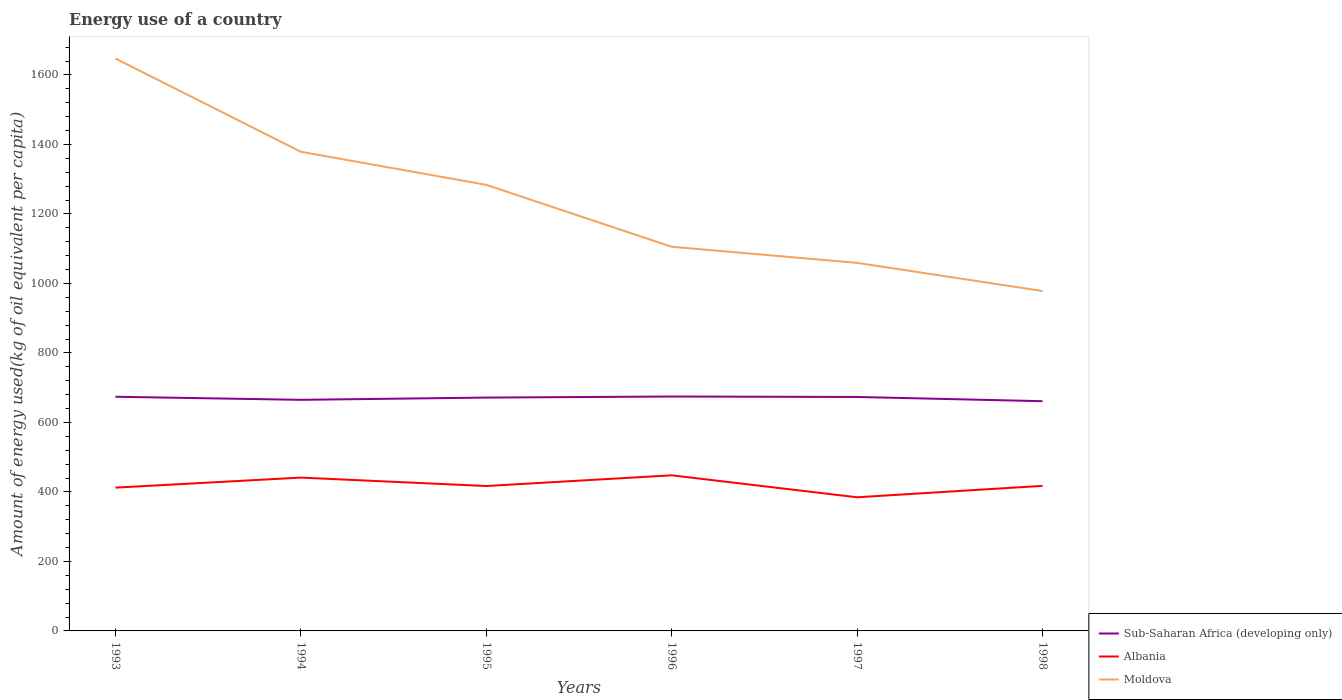Does the line corresponding to Albania intersect with the line corresponding to Moldova?
Provide a succinct answer. No. Is the number of lines equal to the number of legend labels?
Offer a terse response. Yes. Across all years, what is the maximum amount of energy used in in Moldova?
Provide a succinct answer. 978.23. In which year was the amount of energy used in in Sub-Saharan Africa (developing only) maximum?
Make the answer very short. 1998. What is the total amount of energy used in in Sub-Saharan Africa (developing only) in the graph?
Keep it short and to the point. -9.53. What is the difference between the highest and the second highest amount of energy used in in Albania?
Give a very brief answer. 63.25. Is the amount of energy used in in Moldova strictly greater than the amount of energy used in in Albania over the years?
Provide a succinct answer. No. How many lines are there?
Provide a short and direct response. 3. How many years are there in the graph?
Give a very brief answer. 6. What is the difference between two consecutive major ticks on the Y-axis?
Your answer should be very brief. 200. Are the values on the major ticks of Y-axis written in scientific E-notation?
Make the answer very short. No. Does the graph contain any zero values?
Give a very brief answer. No. Does the graph contain grids?
Ensure brevity in your answer.  No. Where does the legend appear in the graph?
Offer a very short reply. Bottom right. How are the legend labels stacked?
Make the answer very short. Vertical. What is the title of the graph?
Make the answer very short. Energy use of a country. What is the label or title of the X-axis?
Your answer should be very brief. Years. What is the label or title of the Y-axis?
Keep it short and to the point. Amount of energy used(kg of oil equivalent per capita). What is the Amount of energy used(kg of oil equivalent per capita) of Sub-Saharan Africa (developing only) in 1993?
Provide a succinct answer. 673.9. What is the Amount of energy used(kg of oil equivalent per capita) in Albania in 1993?
Provide a succinct answer. 412.38. What is the Amount of energy used(kg of oil equivalent per capita) in Moldova in 1993?
Provide a succinct answer. 1647.32. What is the Amount of energy used(kg of oil equivalent per capita) in Sub-Saharan Africa (developing only) in 1994?
Offer a very short reply. 665.05. What is the Amount of energy used(kg of oil equivalent per capita) in Albania in 1994?
Give a very brief answer. 441.25. What is the Amount of energy used(kg of oil equivalent per capita) of Moldova in 1994?
Ensure brevity in your answer.  1378.97. What is the Amount of energy used(kg of oil equivalent per capita) of Sub-Saharan Africa (developing only) in 1995?
Provide a short and direct response. 671.53. What is the Amount of energy used(kg of oil equivalent per capita) of Albania in 1995?
Ensure brevity in your answer.  417.03. What is the Amount of energy used(kg of oil equivalent per capita) of Moldova in 1995?
Make the answer very short. 1283.8. What is the Amount of energy used(kg of oil equivalent per capita) of Sub-Saharan Africa (developing only) in 1996?
Give a very brief answer. 674.58. What is the Amount of energy used(kg of oil equivalent per capita) in Albania in 1996?
Your answer should be compact. 447.85. What is the Amount of energy used(kg of oil equivalent per capita) of Moldova in 1996?
Your response must be concise. 1105.57. What is the Amount of energy used(kg of oil equivalent per capita) of Sub-Saharan Africa (developing only) in 1997?
Provide a succinct answer. 673.28. What is the Amount of energy used(kg of oil equivalent per capita) in Albania in 1997?
Provide a short and direct response. 384.59. What is the Amount of energy used(kg of oil equivalent per capita) of Moldova in 1997?
Give a very brief answer. 1059.24. What is the Amount of energy used(kg of oil equivalent per capita) of Sub-Saharan Africa (developing only) in 1998?
Offer a very short reply. 661.13. What is the Amount of energy used(kg of oil equivalent per capita) of Albania in 1998?
Provide a short and direct response. 417.52. What is the Amount of energy used(kg of oil equivalent per capita) in Moldova in 1998?
Give a very brief answer. 978.23. Across all years, what is the maximum Amount of energy used(kg of oil equivalent per capita) of Sub-Saharan Africa (developing only)?
Your answer should be compact. 674.58. Across all years, what is the maximum Amount of energy used(kg of oil equivalent per capita) of Albania?
Keep it short and to the point. 447.85. Across all years, what is the maximum Amount of energy used(kg of oil equivalent per capita) in Moldova?
Offer a terse response. 1647.32. Across all years, what is the minimum Amount of energy used(kg of oil equivalent per capita) in Sub-Saharan Africa (developing only)?
Offer a very short reply. 661.13. Across all years, what is the minimum Amount of energy used(kg of oil equivalent per capita) in Albania?
Your answer should be compact. 384.59. Across all years, what is the minimum Amount of energy used(kg of oil equivalent per capita) of Moldova?
Your response must be concise. 978.23. What is the total Amount of energy used(kg of oil equivalent per capita) of Sub-Saharan Africa (developing only) in the graph?
Your response must be concise. 4019.47. What is the total Amount of energy used(kg of oil equivalent per capita) in Albania in the graph?
Provide a short and direct response. 2520.63. What is the total Amount of energy used(kg of oil equivalent per capita) of Moldova in the graph?
Your answer should be very brief. 7453.13. What is the difference between the Amount of energy used(kg of oil equivalent per capita) of Sub-Saharan Africa (developing only) in 1993 and that in 1994?
Give a very brief answer. 8.85. What is the difference between the Amount of energy used(kg of oil equivalent per capita) in Albania in 1993 and that in 1994?
Your response must be concise. -28.87. What is the difference between the Amount of energy used(kg of oil equivalent per capita) of Moldova in 1993 and that in 1994?
Your response must be concise. 268.35. What is the difference between the Amount of energy used(kg of oil equivalent per capita) of Sub-Saharan Africa (developing only) in 1993 and that in 1995?
Keep it short and to the point. 2.37. What is the difference between the Amount of energy used(kg of oil equivalent per capita) in Albania in 1993 and that in 1995?
Provide a short and direct response. -4.66. What is the difference between the Amount of energy used(kg of oil equivalent per capita) in Moldova in 1993 and that in 1995?
Provide a short and direct response. 363.52. What is the difference between the Amount of energy used(kg of oil equivalent per capita) of Sub-Saharan Africa (developing only) in 1993 and that in 1996?
Your answer should be very brief. -0.68. What is the difference between the Amount of energy used(kg of oil equivalent per capita) of Albania in 1993 and that in 1996?
Your answer should be very brief. -35.47. What is the difference between the Amount of energy used(kg of oil equivalent per capita) of Moldova in 1993 and that in 1996?
Provide a succinct answer. 541.75. What is the difference between the Amount of energy used(kg of oil equivalent per capita) of Sub-Saharan Africa (developing only) in 1993 and that in 1997?
Provide a succinct answer. 0.62. What is the difference between the Amount of energy used(kg of oil equivalent per capita) of Albania in 1993 and that in 1997?
Offer a terse response. 27.78. What is the difference between the Amount of energy used(kg of oil equivalent per capita) of Moldova in 1993 and that in 1997?
Offer a terse response. 588.08. What is the difference between the Amount of energy used(kg of oil equivalent per capita) in Sub-Saharan Africa (developing only) in 1993 and that in 1998?
Keep it short and to the point. 12.77. What is the difference between the Amount of energy used(kg of oil equivalent per capita) of Albania in 1993 and that in 1998?
Give a very brief answer. -5.14. What is the difference between the Amount of energy used(kg of oil equivalent per capita) in Moldova in 1993 and that in 1998?
Offer a very short reply. 669.09. What is the difference between the Amount of energy used(kg of oil equivalent per capita) of Sub-Saharan Africa (developing only) in 1994 and that in 1995?
Your answer should be very brief. -6.49. What is the difference between the Amount of energy used(kg of oil equivalent per capita) in Albania in 1994 and that in 1995?
Provide a succinct answer. 24.21. What is the difference between the Amount of energy used(kg of oil equivalent per capita) in Moldova in 1994 and that in 1995?
Give a very brief answer. 95.17. What is the difference between the Amount of energy used(kg of oil equivalent per capita) of Sub-Saharan Africa (developing only) in 1994 and that in 1996?
Provide a succinct answer. -9.53. What is the difference between the Amount of energy used(kg of oil equivalent per capita) in Albania in 1994 and that in 1996?
Provide a succinct answer. -6.6. What is the difference between the Amount of energy used(kg of oil equivalent per capita) of Moldova in 1994 and that in 1996?
Provide a succinct answer. 273.4. What is the difference between the Amount of energy used(kg of oil equivalent per capita) of Sub-Saharan Africa (developing only) in 1994 and that in 1997?
Provide a short and direct response. -8.23. What is the difference between the Amount of energy used(kg of oil equivalent per capita) of Albania in 1994 and that in 1997?
Keep it short and to the point. 56.65. What is the difference between the Amount of energy used(kg of oil equivalent per capita) of Moldova in 1994 and that in 1997?
Your answer should be compact. 319.73. What is the difference between the Amount of energy used(kg of oil equivalent per capita) in Sub-Saharan Africa (developing only) in 1994 and that in 1998?
Your response must be concise. 3.91. What is the difference between the Amount of energy used(kg of oil equivalent per capita) of Albania in 1994 and that in 1998?
Ensure brevity in your answer.  23.73. What is the difference between the Amount of energy used(kg of oil equivalent per capita) of Moldova in 1994 and that in 1998?
Provide a succinct answer. 400.74. What is the difference between the Amount of energy used(kg of oil equivalent per capita) of Sub-Saharan Africa (developing only) in 1995 and that in 1996?
Offer a terse response. -3.04. What is the difference between the Amount of energy used(kg of oil equivalent per capita) of Albania in 1995 and that in 1996?
Your response must be concise. -30.81. What is the difference between the Amount of energy used(kg of oil equivalent per capita) in Moldova in 1995 and that in 1996?
Provide a succinct answer. 178.23. What is the difference between the Amount of energy used(kg of oil equivalent per capita) in Sub-Saharan Africa (developing only) in 1995 and that in 1997?
Provide a short and direct response. -1.75. What is the difference between the Amount of energy used(kg of oil equivalent per capita) in Albania in 1995 and that in 1997?
Your answer should be very brief. 32.44. What is the difference between the Amount of energy used(kg of oil equivalent per capita) in Moldova in 1995 and that in 1997?
Keep it short and to the point. 224.55. What is the difference between the Amount of energy used(kg of oil equivalent per capita) of Sub-Saharan Africa (developing only) in 1995 and that in 1998?
Your answer should be very brief. 10.4. What is the difference between the Amount of energy used(kg of oil equivalent per capita) in Albania in 1995 and that in 1998?
Make the answer very short. -0.49. What is the difference between the Amount of energy used(kg of oil equivalent per capita) in Moldova in 1995 and that in 1998?
Your answer should be very brief. 305.57. What is the difference between the Amount of energy used(kg of oil equivalent per capita) in Sub-Saharan Africa (developing only) in 1996 and that in 1997?
Keep it short and to the point. 1.3. What is the difference between the Amount of energy used(kg of oil equivalent per capita) of Albania in 1996 and that in 1997?
Give a very brief answer. 63.25. What is the difference between the Amount of energy used(kg of oil equivalent per capita) in Moldova in 1996 and that in 1997?
Your answer should be compact. 46.33. What is the difference between the Amount of energy used(kg of oil equivalent per capita) of Sub-Saharan Africa (developing only) in 1996 and that in 1998?
Your response must be concise. 13.44. What is the difference between the Amount of energy used(kg of oil equivalent per capita) of Albania in 1996 and that in 1998?
Keep it short and to the point. 30.33. What is the difference between the Amount of energy used(kg of oil equivalent per capita) in Moldova in 1996 and that in 1998?
Keep it short and to the point. 127.34. What is the difference between the Amount of energy used(kg of oil equivalent per capita) of Sub-Saharan Africa (developing only) in 1997 and that in 1998?
Your answer should be very brief. 12.14. What is the difference between the Amount of energy used(kg of oil equivalent per capita) in Albania in 1997 and that in 1998?
Keep it short and to the point. -32.93. What is the difference between the Amount of energy used(kg of oil equivalent per capita) of Moldova in 1997 and that in 1998?
Your answer should be compact. 81.02. What is the difference between the Amount of energy used(kg of oil equivalent per capita) of Sub-Saharan Africa (developing only) in 1993 and the Amount of energy used(kg of oil equivalent per capita) of Albania in 1994?
Your response must be concise. 232.65. What is the difference between the Amount of energy used(kg of oil equivalent per capita) in Sub-Saharan Africa (developing only) in 1993 and the Amount of energy used(kg of oil equivalent per capita) in Moldova in 1994?
Provide a succinct answer. -705.07. What is the difference between the Amount of energy used(kg of oil equivalent per capita) in Albania in 1993 and the Amount of energy used(kg of oil equivalent per capita) in Moldova in 1994?
Your response must be concise. -966.59. What is the difference between the Amount of energy used(kg of oil equivalent per capita) of Sub-Saharan Africa (developing only) in 1993 and the Amount of energy used(kg of oil equivalent per capita) of Albania in 1995?
Your answer should be very brief. 256.86. What is the difference between the Amount of energy used(kg of oil equivalent per capita) in Sub-Saharan Africa (developing only) in 1993 and the Amount of energy used(kg of oil equivalent per capita) in Moldova in 1995?
Offer a very short reply. -609.9. What is the difference between the Amount of energy used(kg of oil equivalent per capita) of Albania in 1993 and the Amount of energy used(kg of oil equivalent per capita) of Moldova in 1995?
Provide a succinct answer. -871.42. What is the difference between the Amount of energy used(kg of oil equivalent per capita) of Sub-Saharan Africa (developing only) in 1993 and the Amount of energy used(kg of oil equivalent per capita) of Albania in 1996?
Make the answer very short. 226.05. What is the difference between the Amount of energy used(kg of oil equivalent per capita) of Sub-Saharan Africa (developing only) in 1993 and the Amount of energy used(kg of oil equivalent per capita) of Moldova in 1996?
Offer a very short reply. -431.67. What is the difference between the Amount of energy used(kg of oil equivalent per capita) in Albania in 1993 and the Amount of energy used(kg of oil equivalent per capita) in Moldova in 1996?
Your answer should be compact. -693.19. What is the difference between the Amount of energy used(kg of oil equivalent per capita) in Sub-Saharan Africa (developing only) in 1993 and the Amount of energy used(kg of oil equivalent per capita) in Albania in 1997?
Your response must be concise. 289.3. What is the difference between the Amount of energy used(kg of oil equivalent per capita) of Sub-Saharan Africa (developing only) in 1993 and the Amount of energy used(kg of oil equivalent per capita) of Moldova in 1997?
Your answer should be very brief. -385.34. What is the difference between the Amount of energy used(kg of oil equivalent per capita) of Albania in 1993 and the Amount of energy used(kg of oil equivalent per capita) of Moldova in 1997?
Keep it short and to the point. -646.86. What is the difference between the Amount of energy used(kg of oil equivalent per capita) in Sub-Saharan Africa (developing only) in 1993 and the Amount of energy used(kg of oil equivalent per capita) in Albania in 1998?
Give a very brief answer. 256.38. What is the difference between the Amount of energy used(kg of oil equivalent per capita) of Sub-Saharan Africa (developing only) in 1993 and the Amount of energy used(kg of oil equivalent per capita) of Moldova in 1998?
Ensure brevity in your answer.  -304.33. What is the difference between the Amount of energy used(kg of oil equivalent per capita) of Albania in 1993 and the Amount of energy used(kg of oil equivalent per capita) of Moldova in 1998?
Give a very brief answer. -565.85. What is the difference between the Amount of energy used(kg of oil equivalent per capita) of Sub-Saharan Africa (developing only) in 1994 and the Amount of energy used(kg of oil equivalent per capita) of Albania in 1995?
Your response must be concise. 248.01. What is the difference between the Amount of energy used(kg of oil equivalent per capita) of Sub-Saharan Africa (developing only) in 1994 and the Amount of energy used(kg of oil equivalent per capita) of Moldova in 1995?
Offer a terse response. -618.75. What is the difference between the Amount of energy used(kg of oil equivalent per capita) of Albania in 1994 and the Amount of energy used(kg of oil equivalent per capita) of Moldova in 1995?
Your response must be concise. -842.55. What is the difference between the Amount of energy used(kg of oil equivalent per capita) in Sub-Saharan Africa (developing only) in 1994 and the Amount of energy used(kg of oil equivalent per capita) in Albania in 1996?
Your answer should be very brief. 217.2. What is the difference between the Amount of energy used(kg of oil equivalent per capita) of Sub-Saharan Africa (developing only) in 1994 and the Amount of energy used(kg of oil equivalent per capita) of Moldova in 1996?
Provide a short and direct response. -440.52. What is the difference between the Amount of energy used(kg of oil equivalent per capita) in Albania in 1994 and the Amount of energy used(kg of oil equivalent per capita) in Moldova in 1996?
Your answer should be very brief. -664.32. What is the difference between the Amount of energy used(kg of oil equivalent per capita) in Sub-Saharan Africa (developing only) in 1994 and the Amount of energy used(kg of oil equivalent per capita) in Albania in 1997?
Make the answer very short. 280.45. What is the difference between the Amount of energy used(kg of oil equivalent per capita) in Sub-Saharan Africa (developing only) in 1994 and the Amount of energy used(kg of oil equivalent per capita) in Moldova in 1997?
Your answer should be compact. -394.2. What is the difference between the Amount of energy used(kg of oil equivalent per capita) of Albania in 1994 and the Amount of energy used(kg of oil equivalent per capita) of Moldova in 1997?
Offer a very short reply. -617.99. What is the difference between the Amount of energy used(kg of oil equivalent per capita) in Sub-Saharan Africa (developing only) in 1994 and the Amount of energy used(kg of oil equivalent per capita) in Albania in 1998?
Give a very brief answer. 247.53. What is the difference between the Amount of energy used(kg of oil equivalent per capita) of Sub-Saharan Africa (developing only) in 1994 and the Amount of energy used(kg of oil equivalent per capita) of Moldova in 1998?
Provide a succinct answer. -313.18. What is the difference between the Amount of energy used(kg of oil equivalent per capita) in Albania in 1994 and the Amount of energy used(kg of oil equivalent per capita) in Moldova in 1998?
Your response must be concise. -536.98. What is the difference between the Amount of energy used(kg of oil equivalent per capita) of Sub-Saharan Africa (developing only) in 1995 and the Amount of energy used(kg of oil equivalent per capita) of Albania in 1996?
Provide a succinct answer. 223.68. What is the difference between the Amount of energy used(kg of oil equivalent per capita) in Sub-Saharan Africa (developing only) in 1995 and the Amount of energy used(kg of oil equivalent per capita) in Moldova in 1996?
Your response must be concise. -434.04. What is the difference between the Amount of energy used(kg of oil equivalent per capita) in Albania in 1995 and the Amount of energy used(kg of oil equivalent per capita) in Moldova in 1996?
Give a very brief answer. -688.53. What is the difference between the Amount of energy used(kg of oil equivalent per capita) of Sub-Saharan Africa (developing only) in 1995 and the Amount of energy used(kg of oil equivalent per capita) of Albania in 1997?
Offer a very short reply. 286.94. What is the difference between the Amount of energy used(kg of oil equivalent per capita) in Sub-Saharan Africa (developing only) in 1995 and the Amount of energy used(kg of oil equivalent per capita) in Moldova in 1997?
Provide a succinct answer. -387.71. What is the difference between the Amount of energy used(kg of oil equivalent per capita) of Albania in 1995 and the Amount of energy used(kg of oil equivalent per capita) of Moldova in 1997?
Offer a terse response. -642.21. What is the difference between the Amount of energy used(kg of oil equivalent per capita) of Sub-Saharan Africa (developing only) in 1995 and the Amount of energy used(kg of oil equivalent per capita) of Albania in 1998?
Your answer should be very brief. 254.01. What is the difference between the Amount of energy used(kg of oil equivalent per capita) of Sub-Saharan Africa (developing only) in 1995 and the Amount of energy used(kg of oil equivalent per capita) of Moldova in 1998?
Make the answer very short. -306.69. What is the difference between the Amount of energy used(kg of oil equivalent per capita) of Albania in 1995 and the Amount of energy used(kg of oil equivalent per capita) of Moldova in 1998?
Offer a very short reply. -561.19. What is the difference between the Amount of energy used(kg of oil equivalent per capita) in Sub-Saharan Africa (developing only) in 1996 and the Amount of energy used(kg of oil equivalent per capita) in Albania in 1997?
Provide a succinct answer. 289.98. What is the difference between the Amount of energy used(kg of oil equivalent per capita) in Sub-Saharan Africa (developing only) in 1996 and the Amount of energy used(kg of oil equivalent per capita) in Moldova in 1997?
Keep it short and to the point. -384.67. What is the difference between the Amount of energy used(kg of oil equivalent per capita) in Albania in 1996 and the Amount of energy used(kg of oil equivalent per capita) in Moldova in 1997?
Provide a short and direct response. -611.39. What is the difference between the Amount of energy used(kg of oil equivalent per capita) of Sub-Saharan Africa (developing only) in 1996 and the Amount of energy used(kg of oil equivalent per capita) of Albania in 1998?
Provide a short and direct response. 257.06. What is the difference between the Amount of energy used(kg of oil equivalent per capita) of Sub-Saharan Africa (developing only) in 1996 and the Amount of energy used(kg of oil equivalent per capita) of Moldova in 1998?
Keep it short and to the point. -303.65. What is the difference between the Amount of energy used(kg of oil equivalent per capita) in Albania in 1996 and the Amount of energy used(kg of oil equivalent per capita) in Moldova in 1998?
Your answer should be compact. -530.38. What is the difference between the Amount of energy used(kg of oil equivalent per capita) in Sub-Saharan Africa (developing only) in 1997 and the Amount of energy used(kg of oil equivalent per capita) in Albania in 1998?
Your answer should be compact. 255.76. What is the difference between the Amount of energy used(kg of oil equivalent per capita) in Sub-Saharan Africa (developing only) in 1997 and the Amount of energy used(kg of oil equivalent per capita) in Moldova in 1998?
Ensure brevity in your answer.  -304.95. What is the difference between the Amount of energy used(kg of oil equivalent per capita) in Albania in 1997 and the Amount of energy used(kg of oil equivalent per capita) in Moldova in 1998?
Provide a short and direct response. -593.63. What is the average Amount of energy used(kg of oil equivalent per capita) in Sub-Saharan Africa (developing only) per year?
Your answer should be compact. 669.91. What is the average Amount of energy used(kg of oil equivalent per capita) in Albania per year?
Your response must be concise. 420.1. What is the average Amount of energy used(kg of oil equivalent per capita) of Moldova per year?
Offer a very short reply. 1242.19. In the year 1993, what is the difference between the Amount of energy used(kg of oil equivalent per capita) in Sub-Saharan Africa (developing only) and Amount of energy used(kg of oil equivalent per capita) in Albania?
Give a very brief answer. 261.52. In the year 1993, what is the difference between the Amount of energy used(kg of oil equivalent per capita) of Sub-Saharan Africa (developing only) and Amount of energy used(kg of oil equivalent per capita) of Moldova?
Keep it short and to the point. -973.42. In the year 1993, what is the difference between the Amount of energy used(kg of oil equivalent per capita) of Albania and Amount of energy used(kg of oil equivalent per capita) of Moldova?
Make the answer very short. -1234.94. In the year 1994, what is the difference between the Amount of energy used(kg of oil equivalent per capita) of Sub-Saharan Africa (developing only) and Amount of energy used(kg of oil equivalent per capita) of Albania?
Offer a very short reply. 223.8. In the year 1994, what is the difference between the Amount of energy used(kg of oil equivalent per capita) of Sub-Saharan Africa (developing only) and Amount of energy used(kg of oil equivalent per capita) of Moldova?
Keep it short and to the point. -713.92. In the year 1994, what is the difference between the Amount of energy used(kg of oil equivalent per capita) of Albania and Amount of energy used(kg of oil equivalent per capita) of Moldova?
Your answer should be very brief. -937.72. In the year 1995, what is the difference between the Amount of energy used(kg of oil equivalent per capita) in Sub-Saharan Africa (developing only) and Amount of energy used(kg of oil equivalent per capita) in Albania?
Your answer should be compact. 254.5. In the year 1995, what is the difference between the Amount of energy used(kg of oil equivalent per capita) in Sub-Saharan Africa (developing only) and Amount of energy used(kg of oil equivalent per capita) in Moldova?
Make the answer very short. -612.26. In the year 1995, what is the difference between the Amount of energy used(kg of oil equivalent per capita) of Albania and Amount of energy used(kg of oil equivalent per capita) of Moldova?
Ensure brevity in your answer.  -866.76. In the year 1996, what is the difference between the Amount of energy used(kg of oil equivalent per capita) in Sub-Saharan Africa (developing only) and Amount of energy used(kg of oil equivalent per capita) in Albania?
Offer a terse response. 226.73. In the year 1996, what is the difference between the Amount of energy used(kg of oil equivalent per capita) of Sub-Saharan Africa (developing only) and Amount of energy used(kg of oil equivalent per capita) of Moldova?
Give a very brief answer. -430.99. In the year 1996, what is the difference between the Amount of energy used(kg of oil equivalent per capita) in Albania and Amount of energy used(kg of oil equivalent per capita) in Moldova?
Make the answer very short. -657.72. In the year 1997, what is the difference between the Amount of energy used(kg of oil equivalent per capita) of Sub-Saharan Africa (developing only) and Amount of energy used(kg of oil equivalent per capita) of Albania?
Offer a very short reply. 288.68. In the year 1997, what is the difference between the Amount of energy used(kg of oil equivalent per capita) of Sub-Saharan Africa (developing only) and Amount of energy used(kg of oil equivalent per capita) of Moldova?
Make the answer very short. -385.97. In the year 1997, what is the difference between the Amount of energy used(kg of oil equivalent per capita) of Albania and Amount of energy used(kg of oil equivalent per capita) of Moldova?
Ensure brevity in your answer.  -674.65. In the year 1998, what is the difference between the Amount of energy used(kg of oil equivalent per capita) of Sub-Saharan Africa (developing only) and Amount of energy used(kg of oil equivalent per capita) of Albania?
Provide a succinct answer. 243.61. In the year 1998, what is the difference between the Amount of energy used(kg of oil equivalent per capita) in Sub-Saharan Africa (developing only) and Amount of energy used(kg of oil equivalent per capita) in Moldova?
Make the answer very short. -317.09. In the year 1998, what is the difference between the Amount of energy used(kg of oil equivalent per capita) of Albania and Amount of energy used(kg of oil equivalent per capita) of Moldova?
Provide a short and direct response. -560.71. What is the ratio of the Amount of energy used(kg of oil equivalent per capita) in Sub-Saharan Africa (developing only) in 1993 to that in 1994?
Keep it short and to the point. 1.01. What is the ratio of the Amount of energy used(kg of oil equivalent per capita) in Albania in 1993 to that in 1994?
Give a very brief answer. 0.93. What is the ratio of the Amount of energy used(kg of oil equivalent per capita) in Moldova in 1993 to that in 1994?
Your answer should be very brief. 1.19. What is the ratio of the Amount of energy used(kg of oil equivalent per capita) in Albania in 1993 to that in 1995?
Provide a short and direct response. 0.99. What is the ratio of the Amount of energy used(kg of oil equivalent per capita) of Moldova in 1993 to that in 1995?
Provide a short and direct response. 1.28. What is the ratio of the Amount of energy used(kg of oil equivalent per capita) of Sub-Saharan Africa (developing only) in 1993 to that in 1996?
Keep it short and to the point. 1. What is the ratio of the Amount of energy used(kg of oil equivalent per capita) in Albania in 1993 to that in 1996?
Your answer should be very brief. 0.92. What is the ratio of the Amount of energy used(kg of oil equivalent per capita) of Moldova in 1993 to that in 1996?
Ensure brevity in your answer.  1.49. What is the ratio of the Amount of energy used(kg of oil equivalent per capita) of Sub-Saharan Africa (developing only) in 1993 to that in 1997?
Provide a short and direct response. 1. What is the ratio of the Amount of energy used(kg of oil equivalent per capita) in Albania in 1993 to that in 1997?
Your response must be concise. 1.07. What is the ratio of the Amount of energy used(kg of oil equivalent per capita) of Moldova in 1993 to that in 1997?
Your answer should be compact. 1.56. What is the ratio of the Amount of energy used(kg of oil equivalent per capita) of Sub-Saharan Africa (developing only) in 1993 to that in 1998?
Make the answer very short. 1.02. What is the ratio of the Amount of energy used(kg of oil equivalent per capita) of Albania in 1993 to that in 1998?
Your answer should be very brief. 0.99. What is the ratio of the Amount of energy used(kg of oil equivalent per capita) of Moldova in 1993 to that in 1998?
Your answer should be compact. 1.68. What is the ratio of the Amount of energy used(kg of oil equivalent per capita) of Sub-Saharan Africa (developing only) in 1994 to that in 1995?
Your answer should be compact. 0.99. What is the ratio of the Amount of energy used(kg of oil equivalent per capita) in Albania in 1994 to that in 1995?
Ensure brevity in your answer.  1.06. What is the ratio of the Amount of energy used(kg of oil equivalent per capita) in Moldova in 1994 to that in 1995?
Give a very brief answer. 1.07. What is the ratio of the Amount of energy used(kg of oil equivalent per capita) in Sub-Saharan Africa (developing only) in 1994 to that in 1996?
Offer a terse response. 0.99. What is the ratio of the Amount of energy used(kg of oil equivalent per capita) of Moldova in 1994 to that in 1996?
Offer a very short reply. 1.25. What is the ratio of the Amount of energy used(kg of oil equivalent per capita) of Sub-Saharan Africa (developing only) in 1994 to that in 1997?
Ensure brevity in your answer.  0.99. What is the ratio of the Amount of energy used(kg of oil equivalent per capita) in Albania in 1994 to that in 1997?
Your response must be concise. 1.15. What is the ratio of the Amount of energy used(kg of oil equivalent per capita) in Moldova in 1994 to that in 1997?
Make the answer very short. 1.3. What is the ratio of the Amount of energy used(kg of oil equivalent per capita) in Sub-Saharan Africa (developing only) in 1994 to that in 1998?
Your answer should be very brief. 1.01. What is the ratio of the Amount of energy used(kg of oil equivalent per capita) in Albania in 1994 to that in 1998?
Your answer should be compact. 1.06. What is the ratio of the Amount of energy used(kg of oil equivalent per capita) in Moldova in 1994 to that in 1998?
Offer a very short reply. 1.41. What is the ratio of the Amount of energy used(kg of oil equivalent per capita) in Sub-Saharan Africa (developing only) in 1995 to that in 1996?
Provide a short and direct response. 1. What is the ratio of the Amount of energy used(kg of oil equivalent per capita) of Albania in 1995 to that in 1996?
Keep it short and to the point. 0.93. What is the ratio of the Amount of energy used(kg of oil equivalent per capita) in Moldova in 1995 to that in 1996?
Provide a succinct answer. 1.16. What is the ratio of the Amount of energy used(kg of oil equivalent per capita) of Sub-Saharan Africa (developing only) in 1995 to that in 1997?
Give a very brief answer. 1. What is the ratio of the Amount of energy used(kg of oil equivalent per capita) in Albania in 1995 to that in 1997?
Give a very brief answer. 1.08. What is the ratio of the Amount of energy used(kg of oil equivalent per capita) in Moldova in 1995 to that in 1997?
Give a very brief answer. 1.21. What is the ratio of the Amount of energy used(kg of oil equivalent per capita) in Sub-Saharan Africa (developing only) in 1995 to that in 1998?
Provide a short and direct response. 1.02. What is the ratio of the Amount of energy used(kg of oil equivalent per capita) of Albania in 1995 to that in 1998?
Ensure brevity in your answer.  1. What is the ratio of the Amount of energy used(kg of oil equivalent per capita) in Moldova in 1995 to that in 1998?
Provide a succinct answer. 1.31. What is the ratio of the Amount of energy used(kg of oil equivalent per capita) in Sub-Saharan Africa (developing only) in 1996 to that in 1997?
Offer a very short reply. 1. What is the ratio of the Amount of energy used(kg of oil equivalent per capita) of Albania in 1996 to that in 1997?
Ensure brevity in your answer.  1.16. What is the ratio of the Amount of energy used(kg of oil equivalent per capita) of Moldova in 1996 to that in 1997?
Keep it short and to the point. 1.04. What is the ratio of the Amount of energy used(kg of oil equivalent per capita) in Sub-Saharan Africa (developing only) in 1996 to that in 1998?
Ensure brevity in your answer.  1.02. What is the ratio of the Amount of energy used(kg of oil equivalent per capita) in Albania in 1996 to that in 1998?
Offer a very short reply. 1.07. What is the ratio of the Amount of energy used(kg of oil equivalent per capita) in Moldova in 1996 to that in 1998?
Offer a very short reply. 1.13. What is the ratio of the Amount of energy used(kg of oil equivalent per capita) of Sub-Saharan Africa (developing only) in 1997 to that in 1998?
Provide a short and direct response. 1.02. What is the ratio of the Amount of energy used(kg of oil equivalent per capita) of Albania in 1997 to that in 1998?
Your response must be concise. 0.92. What is the ratio of the Amount of energy used(kg of oil equivalent per capita) in Moldova in 1997 to that in 1998?
Offer a terse response. 1.08. What is the difference between the highest and the second highest Amount of energy used(kg of oil equivalent per capita) of Sub-Saharan Africa (developing only)?
Make the answer very short. 0.68. What is the difference between the highest and the second highest Amount of energy used(kg of oil equivalent per capita) of Albania?
Your response must be concise. 6.6. What is the difference between the highest and the second highest Amount of energy used(kg of oil equivalent per capita) of Moldova?
Your answer should be compact. 268.35. What is the difference between the highest and the lowest Amount of energy used(kg of oil equivalent per capita) of Sub-Saharan Africa (developing only)?
Provide a succinct answer. 13.44. What is the difference between the highest and the lowest Amount of energy used(kg of oil equivalent per capita) of Albania?
Ensure brevity in your answer.  63.25. What is the difference between the highest and the lowest Amount of energy used(kg of oil equivalent per capita) in Moldova?
Your answer should be very brief. 669.09. 